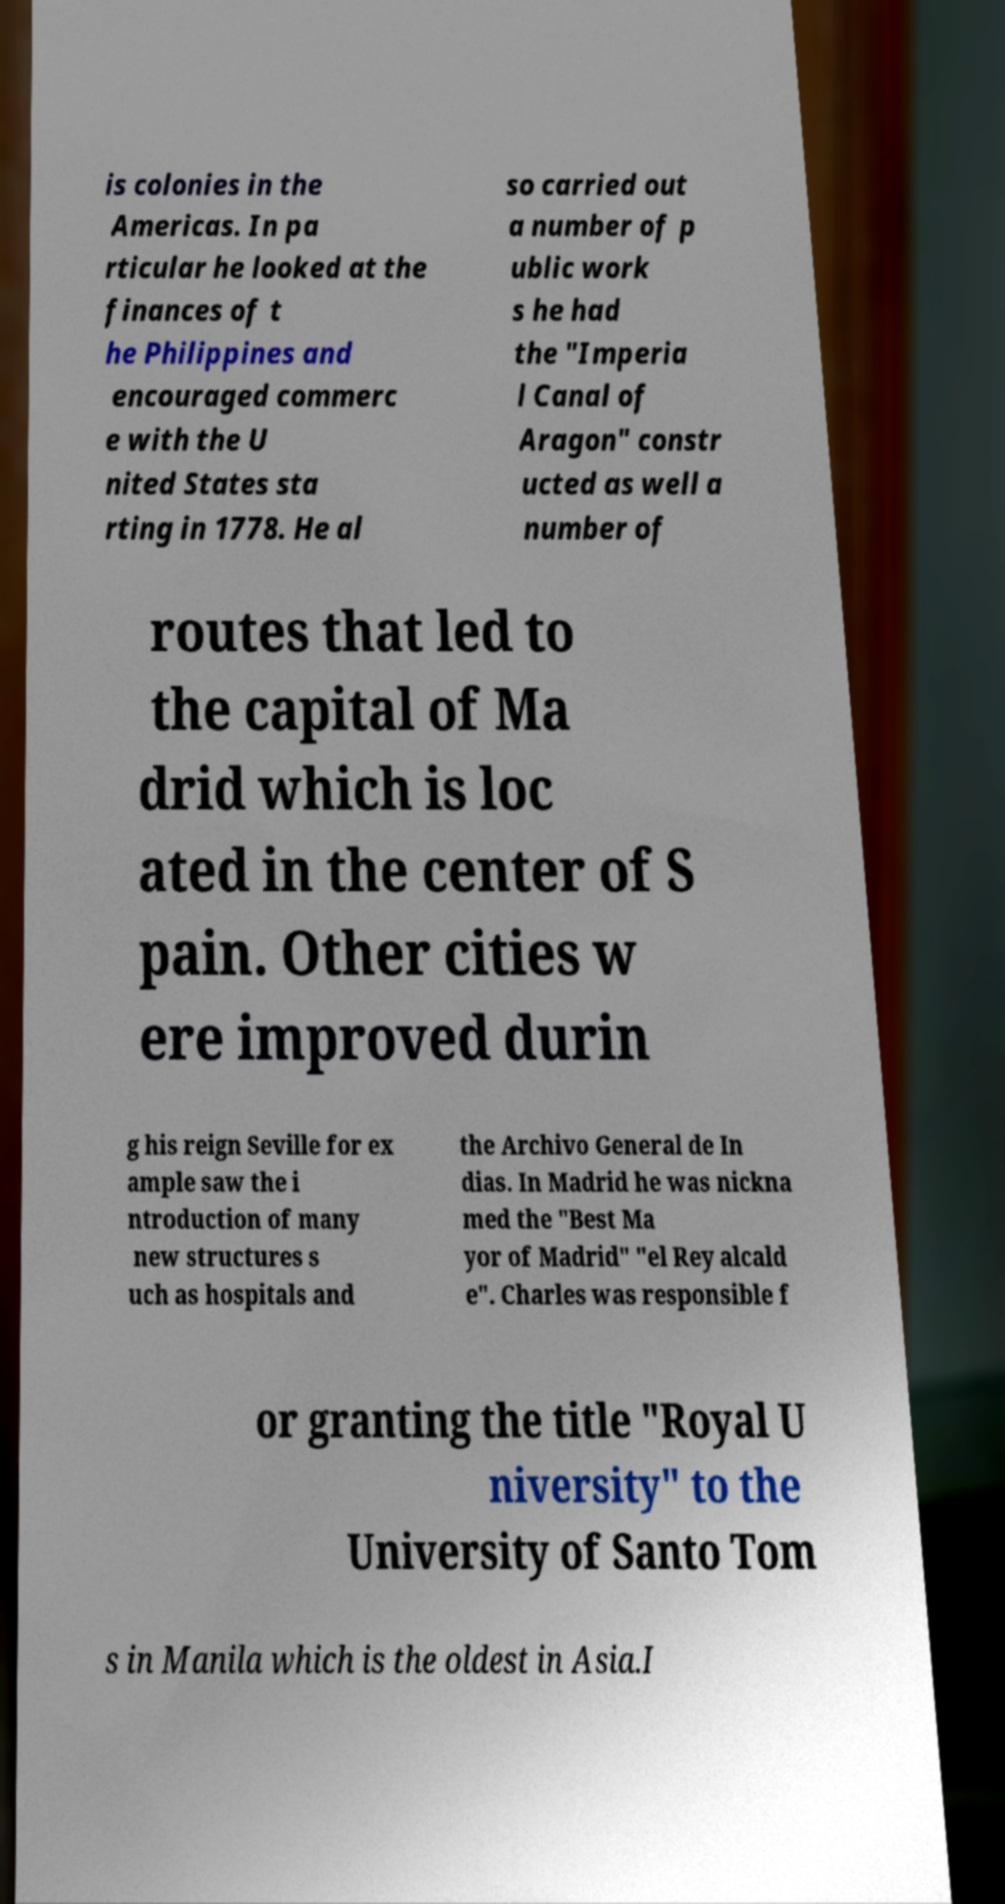For documentation purposes, I need the text within this image transcribed. Could you provide that? is colonies in the Americas. In pa rticular he looked at the finances of t he Philippines and encouraged commerc e with the U nited States sta rting in 1778. He al so carried out a number of p ublic work s he had the "Imperia l Canal of Aragon" constr ucted as well a number of routes that led to the capital of Ma drid which is loc ated in the center of S pain. Other cities w ere improved durin g his reign Seville for ex ample saw the i ntroduction of many new structures s uch as hospitals and the Archivo General de In dias. In Madrid he was nickna med the "Best Ma yor of Madrid" "el Rey alcald e". Charles was responsible f or granting the title "Royal U niversity" to the University of Santo Tom s in Manila which is the oldest in Asia.I 